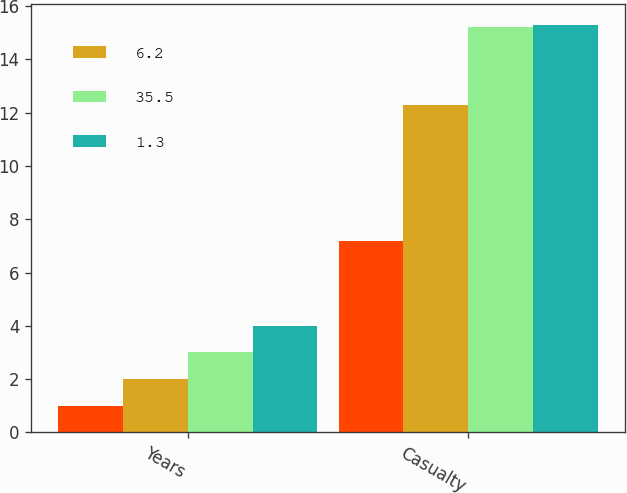<chart> <loc_0><loc_0><loc_500><loc_500><stacked_bar_chart><ecel><fcel>Years<fcel>Casualty<nl><fcel>nan<fcel>1<fcel>7.2<nl><fcel>6.2<fcel>2<fcel>12.3<nl><fcel>35.5<fcel>3<fcel>15.2<nl><fcel>1.3<fcel>4<fcel>15.3<nl></chart> 